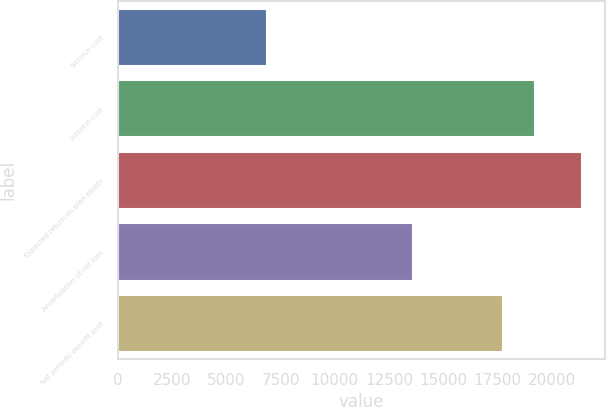Convert chart. <chart><loc_0><loc_0><loc_500><loc_500><bar_chart><fcel>Service cost<fcel>Interest cost<fcel>Expected return on plan assets<fcel>Amortization of net loss<fcel>Net periodic benefit cost<nl><fcel>6896<fcel>19199<fcel>21376<fcel>13586<fcel>17751<nl></chart> 